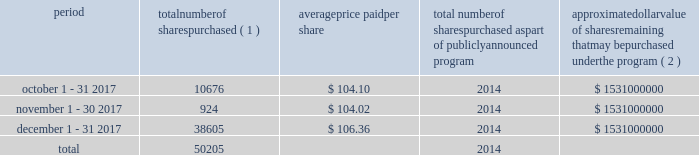Table of contents celanese purchases of its equity securities information regarding repurchases of our common stock during the three months ended december 31 , 2017 is as follows : period number of shares purchased ( 1 ) average price paid per share total number of shares purchased as part of publicly announced program approximate dollar value of shares remaining that may be purchased under the program ( 2 ) .
___________________________ ( 1 ) represents shares withheld from employees to cover their statutory minimum withholding requirements for personal income taxes related to the vesting of restricted stock units .
( 2 ) our board of directors has authorized the aggregate repurchase of $ 3.9 billion of our common stock since february 2008 , including an increase of $ 1.5 billion on july 17 , 2017 .
See note 17 - stockholders' equity in the accompanying consolidated financial statements for further information. .
What is the total authorized the aggregate repurchase of common stock since february 2008 including the additional amount authorized in 2017 in billions? 
Rationale: the total amount is the sum of the amounts
Computations: (3.9 + 1.5)
Answer: 5.4. 